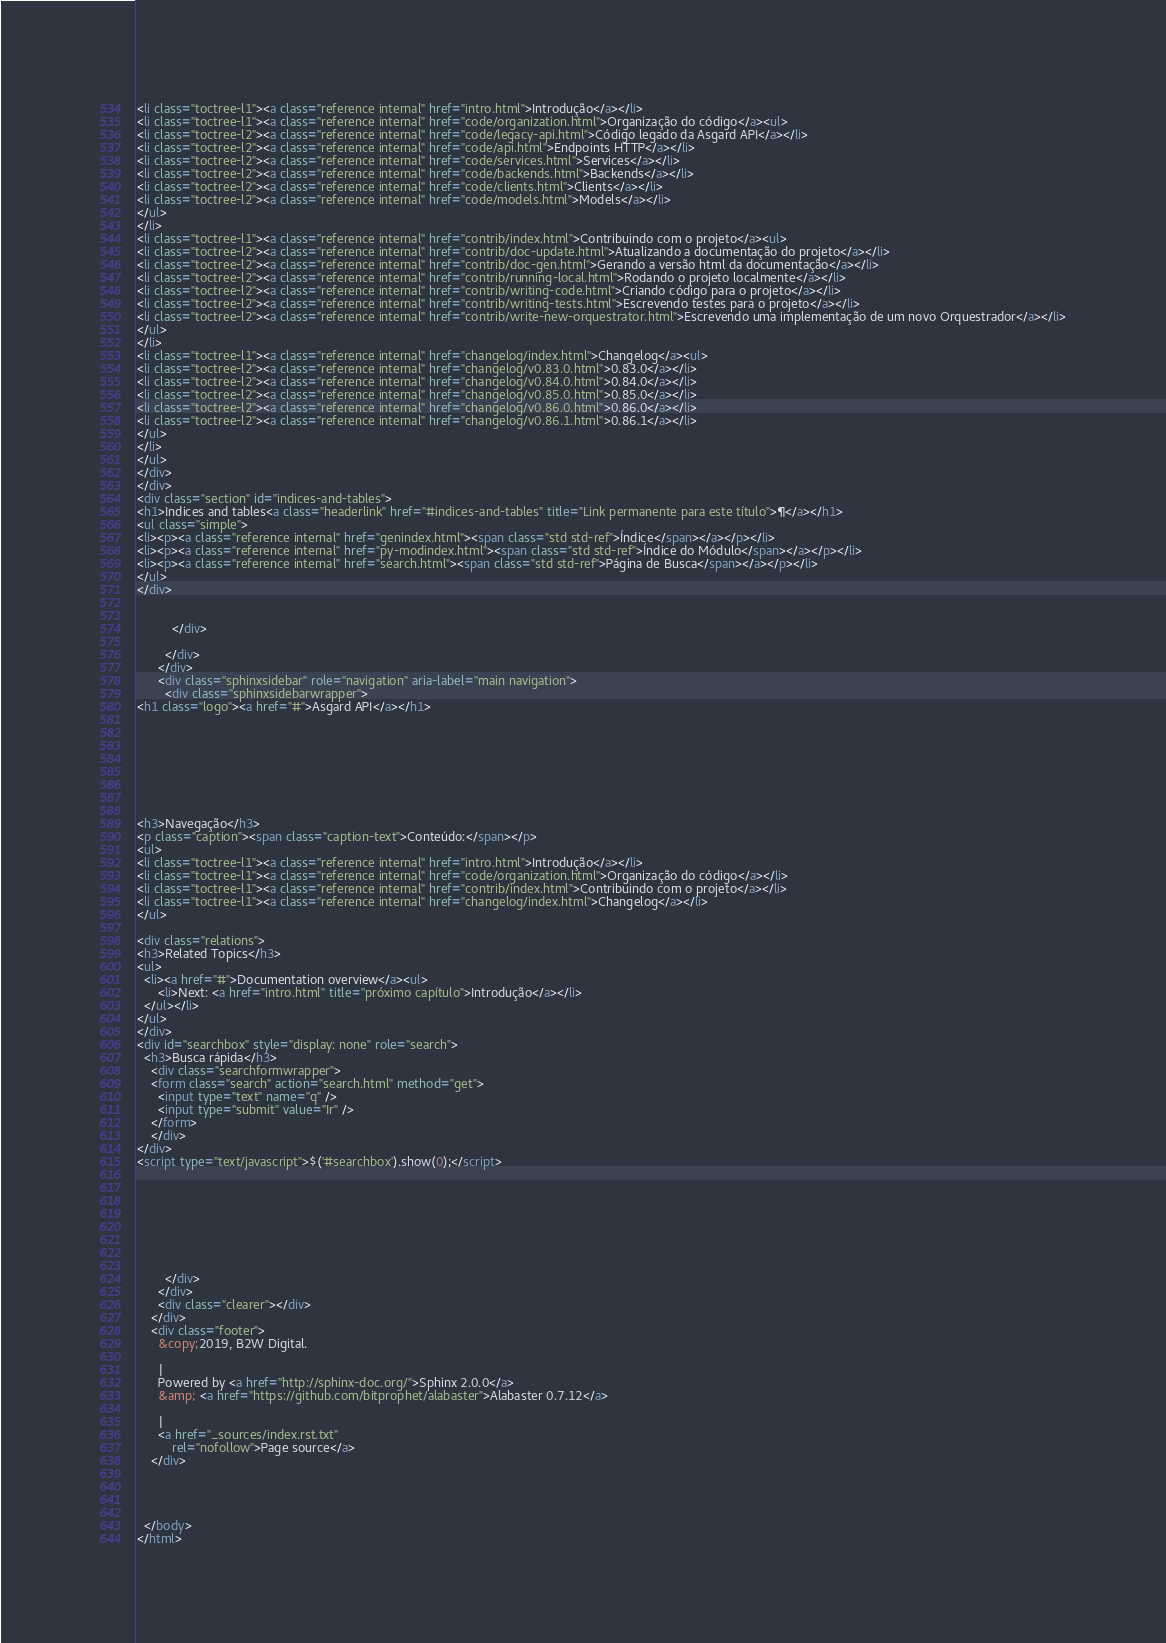Convert code to text. <code><loc_0><loc_0><loc_500><loc_500><_HTML_><li class="toctree-l1"><a class="reference internal" href="intro.html">Introdução</a></li>
<li class="toctree-l1"><a class="reference internal" href="code/organization.html">Organização do código</a><ul>
<li class="toctree-l2"><a class="reference internal" href="code/legacy-api.html">Código legado da Asgard API</a></li>
<li class="toctree-l2"><a class="reference internal" href="code/api.html">Endpoints HTTP</a></li>
<li class="toctree-l2"><a class="reference internal" href="code/services.html">Services</a></li>
<li class="toctree-l2"><a class="reference internal" href="code/backends.html">Backends</a></li>
<li class="toctree-l2"><a class="reference internal" href="code/clients.html">Clients</a></li>
<li class="toctree-l2"><a class="reference internal" href="code/models.html">Models</a></li>
</ul>
</li>
<li class="toctree-l1"><a class="reference internal" href="contrib/index.html">Contribuindo com o projeto</a><ul>
<li class="toctree-l2"><a class="reference internal" href="contrib/doc-update.html">Atualizando a documentação do projeto</a></li>
<li class="toctree-l2"><a class="reference internal" href="contrib/doc-gen.html">Gerando a versão html da documentação</a></li>
<li class="toctree-l2"><a class="reference internal" href="contrib/running-local.html">Rodando o projeto localmente</a></li>
<li class="toctree-l2"><a class="reference internal" href="contrib/writing-code.html">Criando código para o projeto</a></li>
<li class="toctree-l2"><a class="reference internal" href="contrib/writing-tests.html">Escrevendo testes para o projeto</a></li>
<li class="toctree-l2"><a class="reference internal" href="contrib/write-new-orquestrator.html">Escrevendo uma implementação de um novo Orquestrador</a></li>
</ul>
</li>
<li class="toctree-l1"><a class="reference internal" href="changelog/index.html">Changelog</a><ul>
<li class="toctree-l2"><a class="reference internal" href="changelog/v0.83.0.html">0.83.0</a></li>
<li class="toctree-l2"><a class="reference internal" href="changelog/v0.84.0.html">0.84.0</a></li>
<li class="toctree-l2"><a class="reference internal" href="changelog/v0.85.0.html">0.85.0</a></li>
<li class="toctree-l2"><a class="reference internal" href="changelog/v0.86.0.html">0.86.0</a></li>
<li class="toctree-l2"><a class="reference internal" href="changelog/v0.86.1.html">0.86.1</a></li>
</ul>
</li>
</ul>
</div>
</div>
<div class="section" id="indices-and-tables">
<h1>Indices and tables<a class="headerlink" href="#indices-and-tables" title="Link permanente para este título">¶</a></h1>
<ul class="simple">
<li><p><a class="reference internal" href="genindex.html"><span class="std std-ref">Índice</span></a></p></li>
<li><p><a class="reference internal" href="py-modindex.html"><span class="std std-ref">Índice do Módulo</span></a></p></li>
<li><p><a class="reference internal" href="search.html"><span class="std std-ref">Página de Busca</span></a></p></li>
</ul>
</div>


          </div>
          
        </div>
      </div>
      <div class="sphinxsidebar" role="navigation" aria-label="main navigation">
        <div class="sphinxsidebarwrapper">
<h1 class="logo"><a href="#">Asgard API</a></h1>








<h3>Navegação</h3>
<p class="caption"><span class="caption-text">Conteúdo:</span></p>
<ul>
<li class="toctree-l1"><a class="reference internal" href="intro.html">Introdução</a></li>
<li class="toctree-l1"><a class="reference internal" href="code/organization.html">Organização do código</a></li>
<li class="toctree-l1"><a class="reference internal" href="contrib/index.html">Contribuindo com o projeto</a></li>
<li class="toctree-l1"><a class="reference internal" href="changelog/index.html">Changelog</a></li>
</ul>

<div class="relations">
<h3>Related Topics</h3>
<ul>
  <li><a href="#">Documentation overview</a><ul>
      <li>Next: <a href="intro.html" title="próximo capítulo">Introdução</a></li>
  </ul></li>
</ul>
</div>
<div id="searchbox" style="display: none" role="search">
  <h3>Busca rápida</h3>
    <div class="searchformwrapper">
    <form class="search" action="search.html" method="get">
      <input type="text" name="q" />
      <input type="submit" value="Ir" />
    </form>
    </div>
</div>
<script type="text/javascript">$('#searchbox').show(0);</script>








        </div>
      </div>
      <div class="clearer"></div>
    </div>
    <div class="footer">
      &copy;2019, B2W Digital.
      
      |
      Powered by <a href="http://sphinx-doc.org/">Sphinx 2.0.0</a>
      &amp; <a href="https://github.com/bitprophet/alabaster">Alabaster 0.7.12</a>
      
      |
      <a href="_sources/index.rst.txt"
          rel="nofollow">Page source</a>
    </div>

    

    
  </body>
</html></code> 